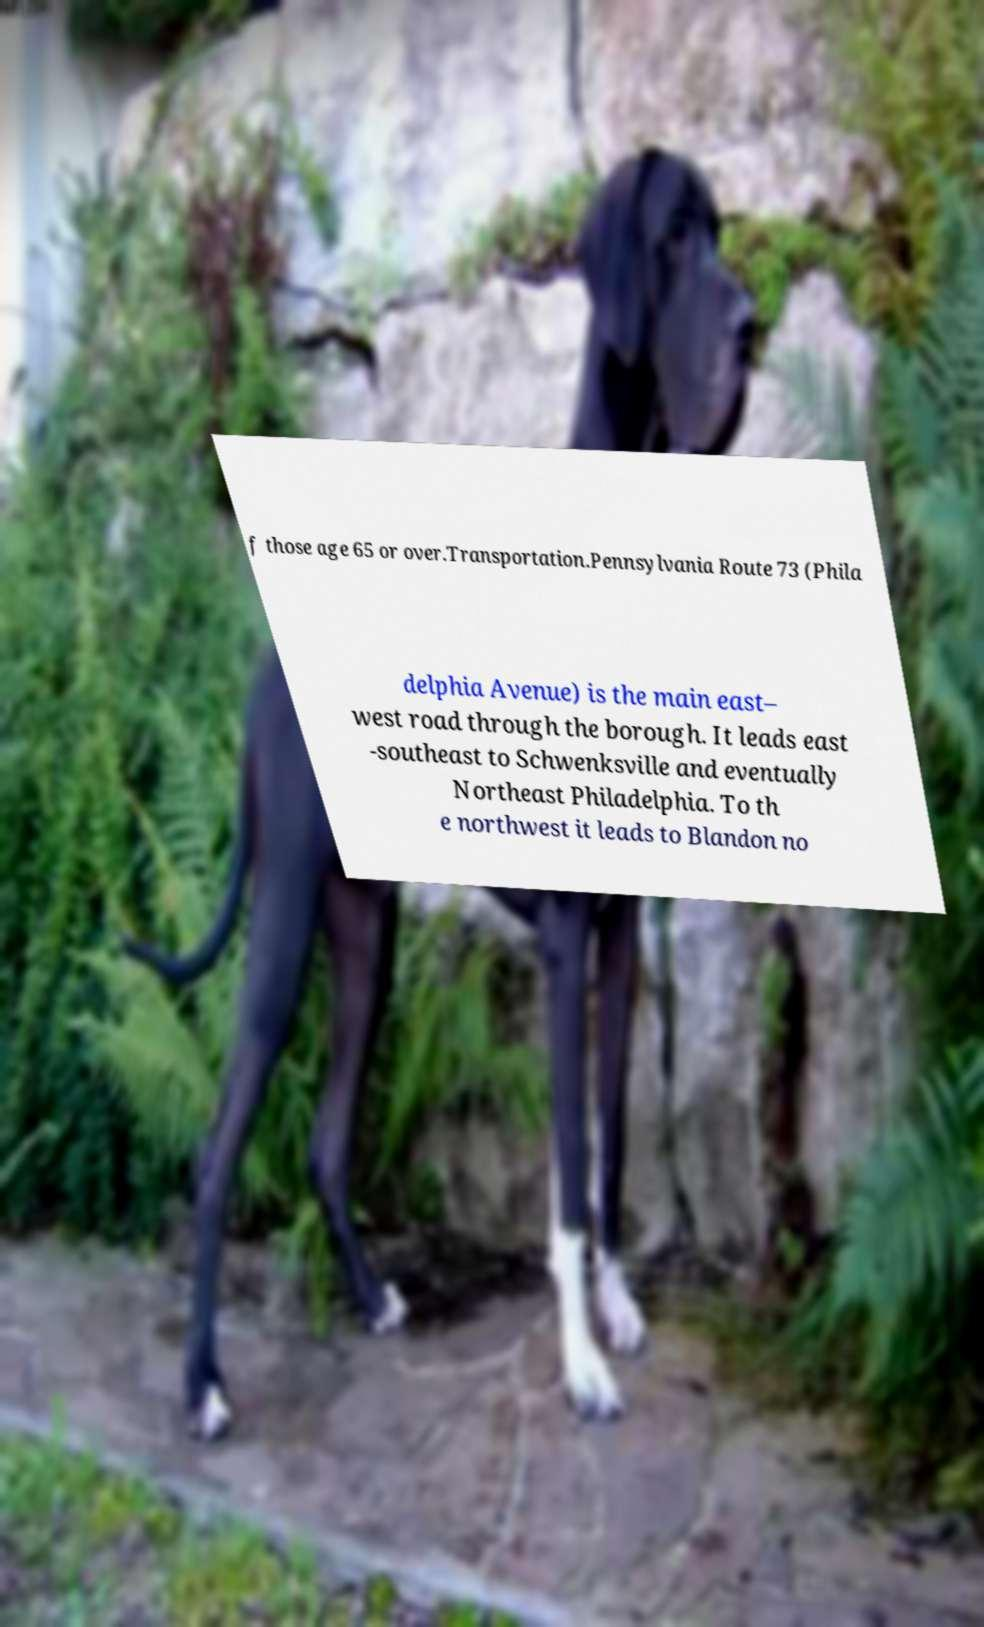Could you assist in decoding the text presented in this image and type it out clearly? f those age 65 or over.Transportation.Pennsylvania Route 73 (Phila delphia Avenue) is the main east– west road through the borough. It leads east -southeast to Schwenksville and eventually Northeast Philadelphia. To th e northwest it leads to Blandon no 